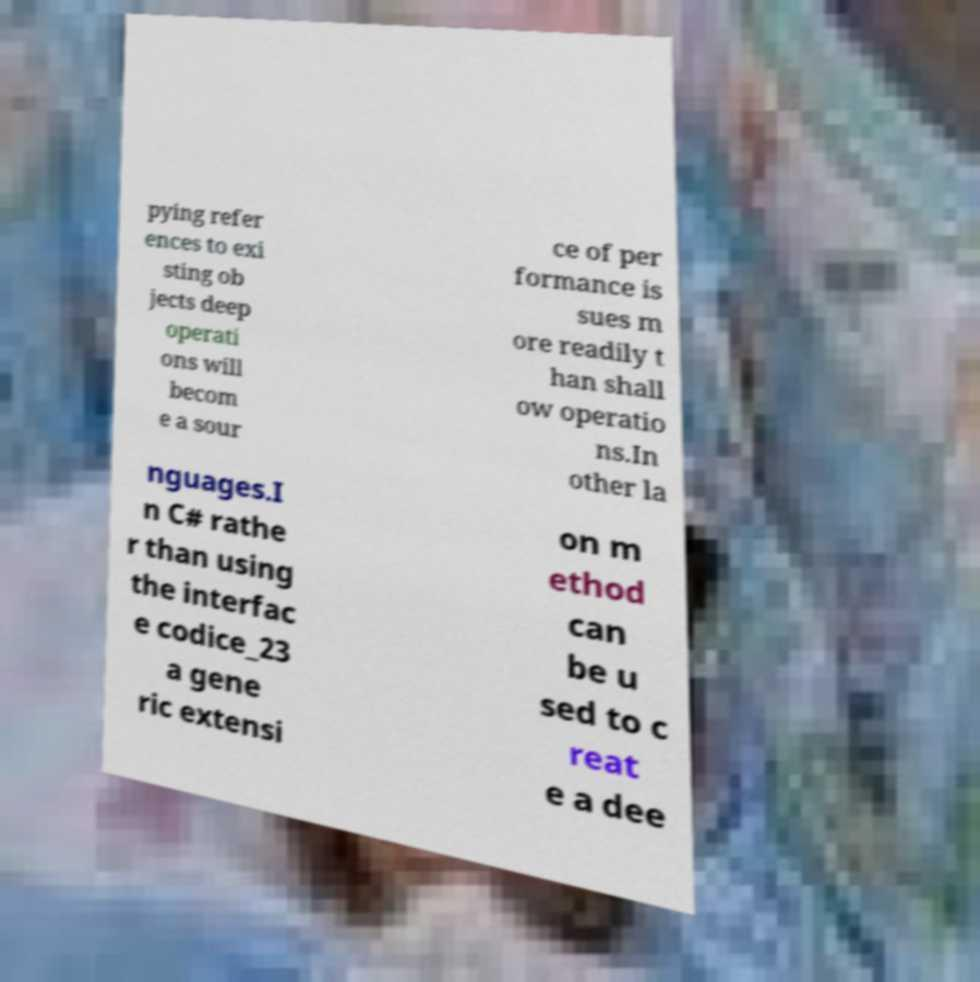There's text embedded in this image that I need extracted. Can you transcribe it verbatim? pying refer ences to exi sting ob jects deep operati ons will becom e a sour ce of per formance is sues m ore readily t han shall ow operatio ns.In other la nguages.I n C# rathe r than using the interfac e codice_23 a gene ric extensi on m ethod can be u sed to c reat e a dee 